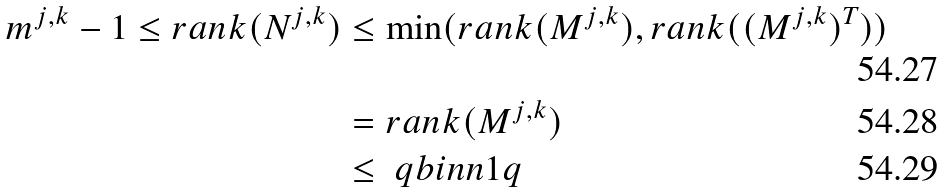<formula> <loc_0><loc_0><loc_500><loc_500>m ^ { j , k } - 1 \leq r a n k ( N ^ { j , k } ) & \leq \min ( r a n k ( M ^ { j , k } ) , r a n k ( ( M ^ { j , k } ) ^ { T } ) ) \\ & = r a n k ( M ^ { j , k } ) \\ & \leq \ q b i n { n } { 1 } { q }</formula> 